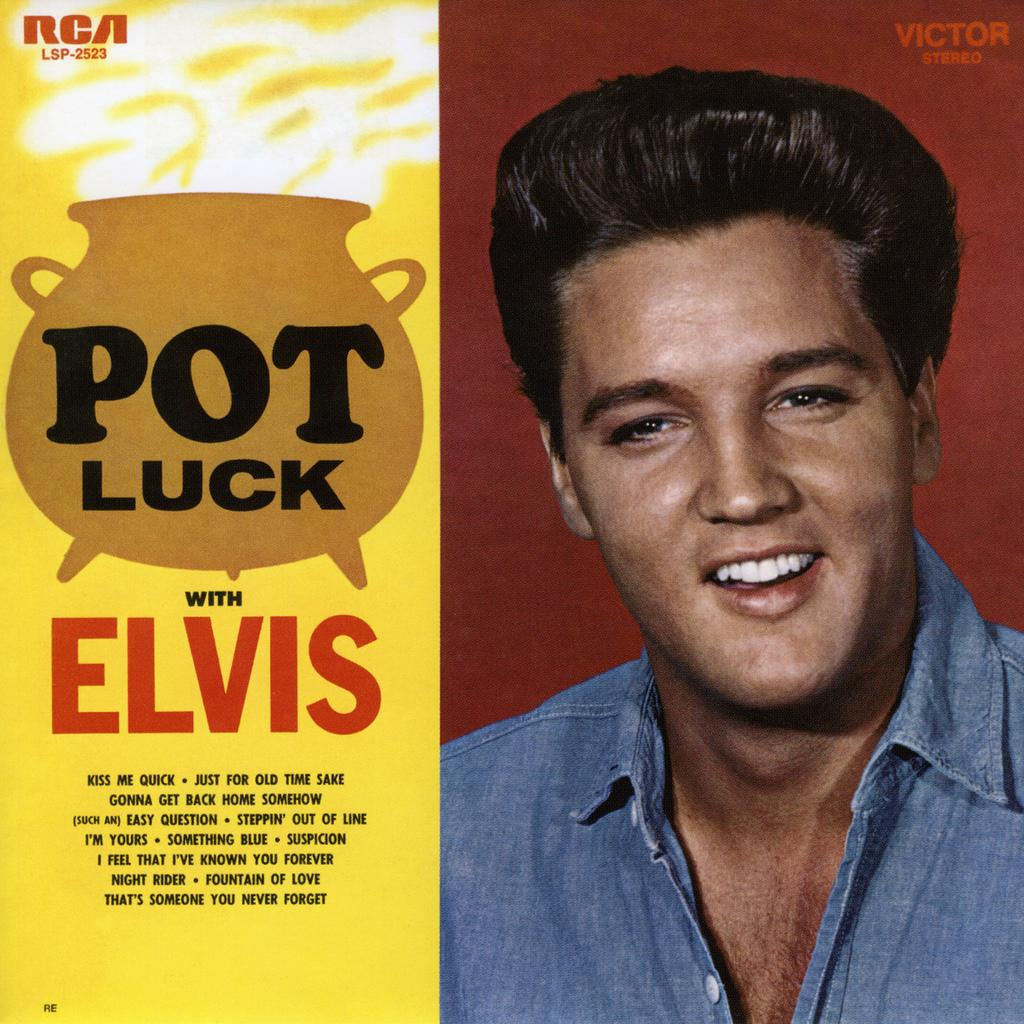What type of image is being shown? The image is an edited picture. What is the main subject of the edited picture? The edited picture contains a person. Are there any additional elements present in the edited picture? Yes, there is text present on the edited picture. What type of property is being shown in the image? There is no property present in the image; it features an edited picture of a person with text. Can you tell me how many people are driving in the image? There is no driving activity present in the image. What type of lift is being used by the person in the image? There is no lift present in the image; it features an edited picture of a person with text. 